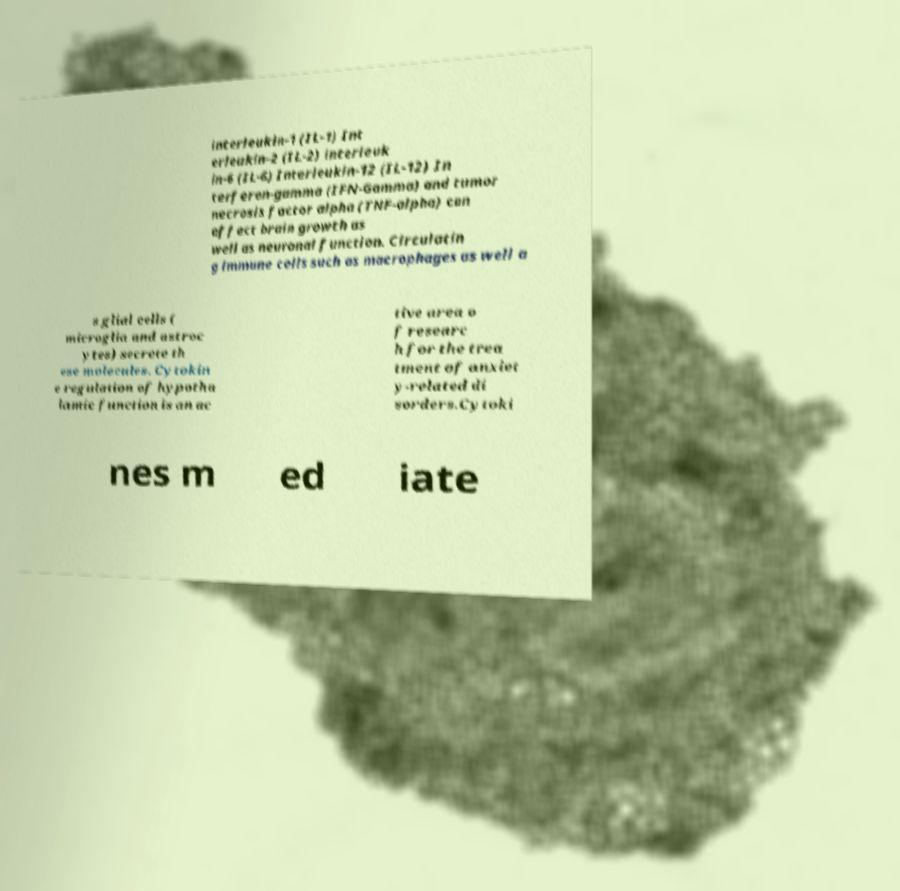Can you read and provide the text displayed in the image?This photo seems to have some interesting text. Can you extract and type it out for me? interleukin-1 (IL-1) Int erleukin-2 (IL-2) interleuk in-6 (IL-6) Interleukin-12 (IL-12) In terferon-gamma (IFN-Gamma) and tumor necrosis factor alpha (TNF-alpha) can affect brain growth as well as neuronal function. Circulatin g immune cells such as macrophages as well a s glial cells ( microglia and astroc ytes) secrete th ese molecules. Cytokin e regulation of hypotha lamic function is an ac tive area o f researc h for the trea tment of anxiet y-related di sorders.Cytoki nes m ed iate 